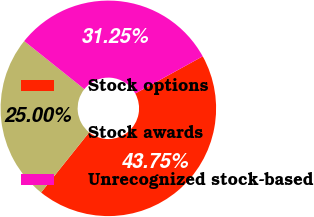Convert chart. <chart><loc_0><loc_0><loc_500><loc_500><pie_chart><fcel>Stock options<fcel>Stock awards<fcel>Unrecognized stock-based<nl><fcel>43.75%<fcel>25.0%<fcel>31.25%<nl></chart> 